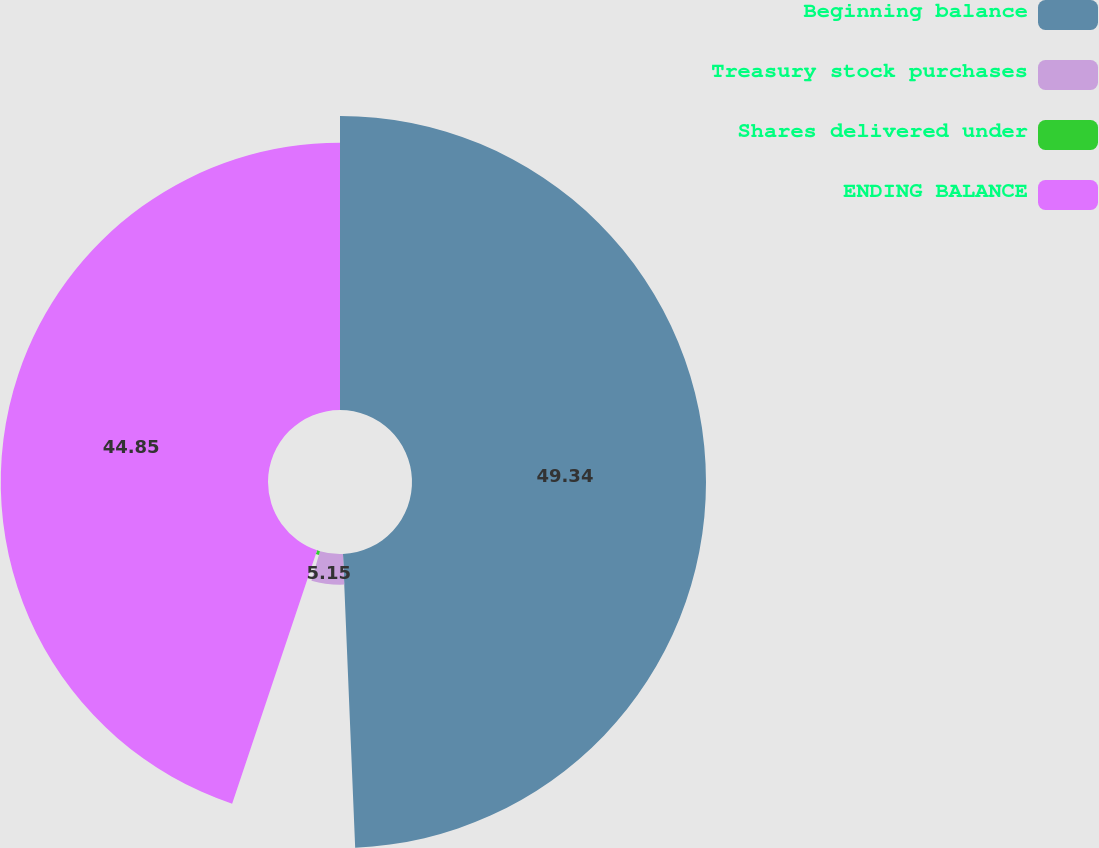Convert chart. <chart><loc_0><loc_0><loc_500><loc_500><pie_chart><fcel>Beginning balance<fcel>Treasury stock purchases<fcel>Shares delivered under<fcel>ENDING BALANCE<nl><fcel>49.34%<fcel>5.15%<fcel>0.66%<fcel>44.85%<nl></chart> 